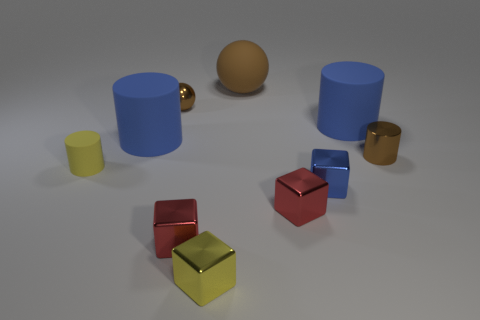What color is the small cylinder that is made of the same material as the tiny blue thing?
Give a very brief answer. Brown. How many cylinders are either small blue shiny objects or large blue rubber things?
Your response must be concise. 2. How many objects are yellow rubber things or metal things behind the tiny blue metallic object?
Offer a terse response. 3. Are there any large blue cylinders?
Keep it short and to the point. Yes. How many big rubber things have the same color as the small shiny cylinder?
Your response must be concise. 1. There is a small ball that is the same color as the large ball; what is its material?
Provide a short and direct response. Metal. How big is the brown metallic object to the right of the small metallic thing behind the tiny metallic cylinder?
Your answer should be compact. Small. Are there any small yellow objects that have the same material as the tiny brown cylinder?
Your answer should be compact. Yes. There is a brown cylinder that is the same size as the blue metallic thing; what material is it?
Offer a terse response. Metal. There is a big rubber cylinder right of the small brown metallic ball; is its color the same as the large cylinder that is on the left side of the brown matte thing?
Provide a short and direct response. Yes. 